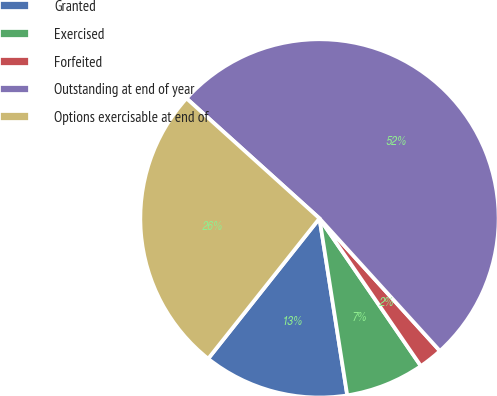Convert chart. <chart><loc_0><loc_0><loc_500><loc_500><pie_chart><fcel>Granted<fcel>Exercised<fcel>Forfeited<fcel>Outstanding at end of year<fcel>Options exercisable at end of<nl><fcel>13.15%<fcel>7.1%<fcel>2.16%<fcel>51.57%<fcel>26.01%<nl></chart> 